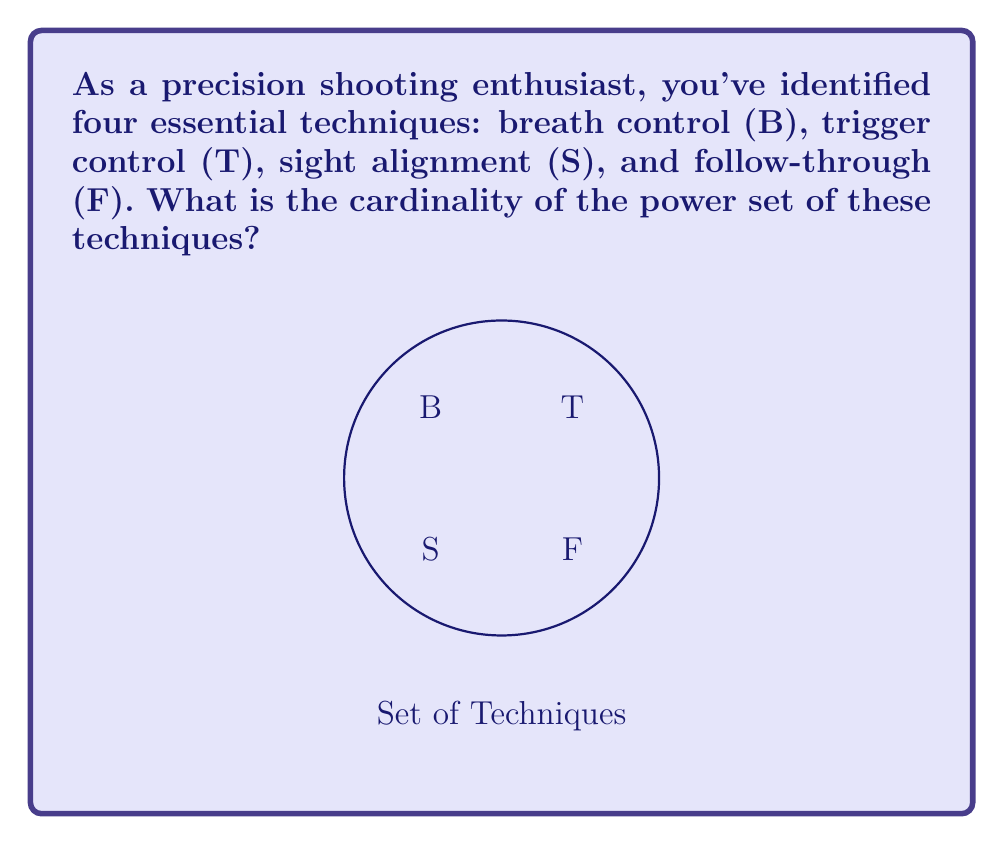Show me your answer to this math problem. Let's approach this step-by-step:

1) First, recall that the power set of a set A is the set of all subsets of A, including the empty set and A itself.

2) Our set of precision shooting techniques is $A = \{B, T, S, F\}$.

3) To find the cardinality of the power set, we can use the formula:
   $|P(A)| = 2^n$, where n is the number of elements in the original set A.

4) In this case, $n = 4$ (B, T, S, F).

5) Therefore, the cardinality of the power set is:
   $|P(A)| = 2^4 = 16$

6) To verify, we can list all subsets:
   - Empty set: $\{\}$
   - Single element sets: $\{B\}, \{T\}, \{S\}, \{F\}$
   - Two element sets: $\{B,T\}, \{B,S\}, \{B,F\}, \{T,S\}, \{T,F\}, \{S,F\}$
   - Three element sets: $\{B,T,S\}, \{B,T,F\}, \{B,S,F\}, \{T,S,F\}$
   - The full set: $\{B,T,S,F\}$

Indeed, there are 16 subsets in total.
Answer: 16 